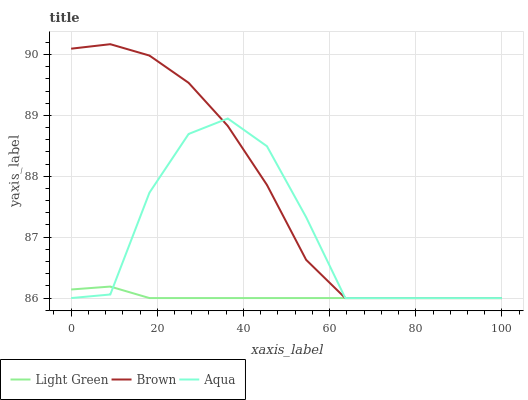Does Light Green have the minimum area under the curve?
Answer yes or no. Yes. Does Brown have the maximum area under the curve?
Answer yes or no. Yes. Does Aqua have the minimum area under the curve?
Answer yes or no. No. Does Aqua have the maximum area under the curve?
Answer yes or no. No. Is Light Green the smoothest?
Answer yes or no. Yes. Is Aqua the roughest?
Answer yes or no. Yes. Is Aqua the smoothest?
Answer yes or no. No. Is Light Green the roughest?
Answer yes or no. No. Does Brown have the lowest value?
Answer yes or no. Yes. Does Brown have the highest value?
Answer yes or no. Yes. Does Aqua have the highest value?
Answer yes or no. No. Does Brown intersect Light Green?
Answer yes or no. Yes. Is Brown less than Light Green?
Answer yes or no. No. Is Brown greater than Light Green?
Answer yes or no. No. 